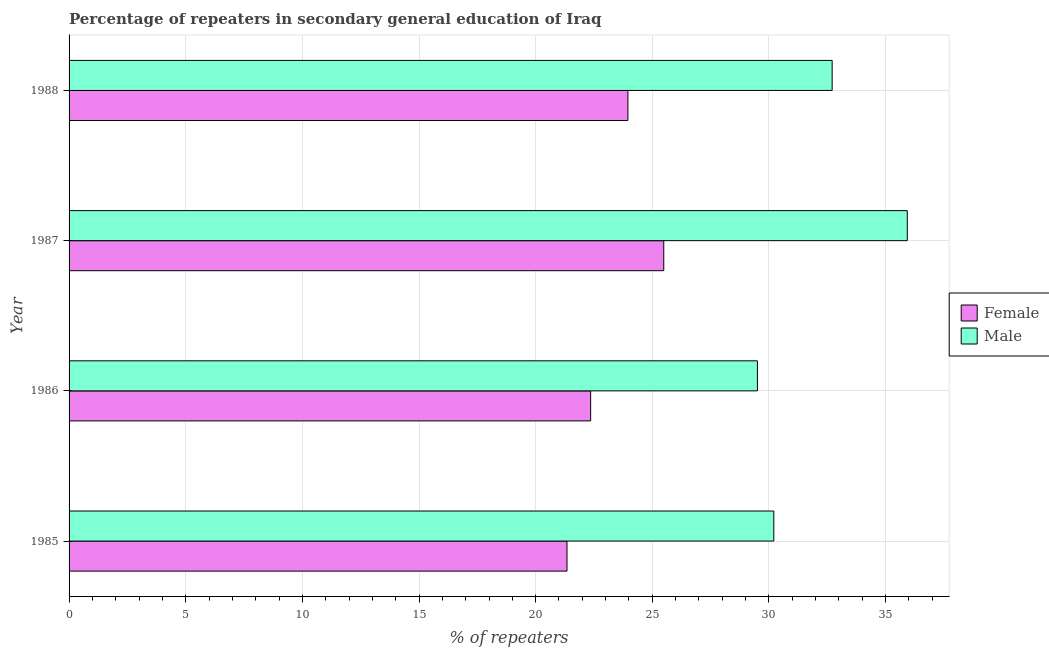How many groups of bars are there?
Give a very brief answer. 4. Are the number of bars on each tick of the Y-axis equal?
Your answer should be compact. Yes. How many bars are there on the 3rd tick from the bottom?
Your answer should be very brief. 2. What is the label of the 4th group of bars from the top?
Make the answer very short. 1985. In how many cases, is the number of bars for a given year not equal to the number of legend labels?
Your response must be concise. 0. What is the percentage of male repeaters in 1986?
Make the answer very short. 29.51. Across all years, what is the maximum percentage of female repeaters?
Make the answer very short. 25.49. Across all years, what is the minimum percentage of male repeaters?
Keep it short and to the point. 29.51. In which year was the percentage of female repeaters minimum?
Your answer should be very brief. 1985. What is the total percentage of male repeaters in the graph?
Your answer should be compact. 128.35. What is the difference between the percentage of male repeaters in 1985 and that in 1988?
Provide a short and direct response. -2.5. What is the difference between the percentage of female repeaters in 1985 and the percentage of male repeaters in 1987?
Ensure brevity in your answer.  -14.59. What is the average percentage of male repeaters per year?
Make the answer very short. 32.09. In the year 1985, what is the difference between the percentage of male repeaters and percentage of female repeaters?
Make the answer very short. 8.87. What is the ratio of the percentage of female repeaters in 1985 to that in 1988?
Your answer should be compact. 0.89. Is the percentage of male repeaters in 1986 less than that in 1988?
Provide a succinct answer. Yes. What is the difference between the highest and the second highest percentage of male repeaters?
Give a very brief answer. 3.22. What is the difference between the highest and the lowest percentage of female repeaters?
Ensure brevity in your answer.  4.15. How many bars are there?
Ensure brevity in your answer.  8. Are all the bars in the graph horizontal?
Give a very brief answer. Yes. How many years are there in the graph?
Your answer should be compact. 4. Does the graph contain any zero values?
Offer a very short reply. No. How many legend labels are there?
Make the answer very short. 2. How are the legend labels stacked?
Offer a very short reply. Vertical. What is the title of the graph?
Your answer should be very brief. Percentage of repeaters in secondary general education of Iraq. What is the label or title of the X-axis?
Provide a short and direct response. % of repeaters. What is the % of repeaters in Female in 1985?
Keep it short and to the point. 21.34. What is the % of repeaters of Male in 1985?
Your answer should be very brief. 30.21. What is the % of repeaters in Female in 1986?
Provide a succinct answer. 22.36. What is the % of repeaters in Male in 1986?
Offer a very short reply. 29.51. What is the % of repeaters of Female in 1987?
Provide a succinct answer. 25.49. What is the % of repeaters of Male in 1987?
Ensure brevity in your answer.  35.93. What is the % of repeaters in Female in 1988?
Make the answer very short. 23.95. What is the % of repeaters of Male in 1988?
Offer a terse response. 32.71. Across all years, what is the maximum % of repeaters of Female?
Provide a succinct answer. 25.49. Across all years, what is the maximum % of repeaters of Male?
Ensure brevity in your answer.  35.93. Across all years, what is the minimum % of repeaters of Female?
Your response must be concise. 21.34. Across all years, what is the minimum % of repeaters in Male?
Provide a short and direct response. 29.51. What is the total % of repeaters of Female in the graph?
Provide a short and direct response. 93.15. What is the total % of repeaters in Male in the graph?
Offer a terse response. 128.35. What is the difference between the % of repeaters in Female in 1985 and that in 1986?
Provide a short and direct response. -1.01. What is the difference between the % of repeaters in Male in 1985 and that in 1986?
Provide a succinct answer. 0.7. What is the difference between the % of repeaters of Female in 1985 and that in 1987?
Provide a short and direct response. -4.15. What is the difference between the % of repeaters in Male in 1985 and that in 1987?
Ensure brevity in your answer.  -5.72. What is the difference between the % of repeaters in Female in 1985 and that in 1988?
Ensure brevity in your answer.  -2.61. What is the difference between the % of repeaters in Male in 1985 and that in 1988?
Offer a very short reply. -2.5. What is the difference between the % of repeaters of Female in 1986 and that in 1987?
Provide a succinct answer. -3.13. What is the difference between the % of repeaters in Male in 1986 and that in 1987?
Keep it short and to the point. -6.42. What is the difference between the % of repeaters of Female in 1986 and that in 1988?
Provide a succinct answer. -1.6. What is the difference between the % of repeaters of Male in 1986 and that in 1988?
Offer a terse response. -3.2. What is the difference between the % of repeaters of Female in 1987 and that in 1988?
Offer a terse response. 1.54. What is the difference between the % of repeaters of Male in 1987 and that in 1988?
Provide a succinct answer. 3.22. What is the difference between the % of repeaters of Female in 1985 and the % of repeaters of Male in 1986?
Ensure brevity in your answer.  -8.16. What is the difference between the % of repeaters of Female in 1985 and the % of repeaters of Male in 1987?
Your answer should be compact. -14.59. What is the difference between the % of repeaters in Female in 1985 and the % of repeaters in Male in 1988?
Your answer should be very brief. -11.37. What is the difference between the % of repeaters in Female in 1986 and the % of repeaters in Male in 1987?
Offer a very short reply. -13.57. What is the difference between the % of repeaters of Female in 1986 and the % of repeaters of Male in 1988?
Give a very brief answer. -10.35. What is the difference between the % of repeaters of Female in 1987 and the % of repeaters of Male in 1988?
Ensure brevity in your answer.  -7.22. What is the average % of repeaters in Female per year?
Your answer should be very brief. 23.29. What is the average % of repeaters of Male per year?
Offer a very short reply. 32.09. In the year 1985, what is the difference between the % of repeaters in Female and % of repeaters in Male?
Make the answer very short. -8.87. In the year 1986, what is the difference between the % of repeaters of Female and % of repeaters of Male?
Your answer should be very brief. -7.15. In the year 1987, what is the difference between the % of repeaters of Female and % of repeaters of Male?
Offer a terse response. -10.44. In the year 1988, what is the difference between the % of repeaters in Female and % of repeaters in Male?
Keep it short and to the point. -8.75. What is the ratio of the % of repeaters in Female in 1985 to that in 1986?
Offer a very short reply. 0.95. What is the ratio of the % of repeaters of Male in 1985 to that in 1986?
Offer a terse response. 1.02. What is the ratio of the % of repeaters of Female in 1985 to that in 1987?
Make the answer very short. 0.84. What is the ratio of the % of repeaters in Male in 1985 to that in 1987?
Ensure brevity in your answer.  0.84. What is the ratio of the % of repeaters in Female in 1985 to that in 1988?
Give a very brief answer. 0.89. What is the ratio of the % of repeaters in Male in 1985 to that in 1988?
Your answer should be very brief. 0.92. What is the ratio of the % of repeaters of Female in 1986 to that in 1987?
Your answer should be very brief. 0.88. What is the ratio of the % of repeaters of Male in 1986 to that in 1987?
Your answer should be very brief. 0.82. What is the ratio of the % of repeaters in Female in 1986 to that in 1988?
Provide a succinct answer. 0.93. What is the ratio of the % of repeaters in Male in 1986 to that in 1988?
Your answer should be very brief. 0.9. What is the ratio of the % of repeaters of Female in 1987 to that in 1988?
Your response must be concise. 1.06. What is the ratio of the % of repeaters in Male in 1987 to that in 1988?
Provide a succinct answer. 1.1. What is the difference between the highest and the second highest % of repeaters of Female?
Offer a very short reply. 1.54. What is the difference between the highest and the second highest % of repeaters of Male?
Your answer should be compact. 3.22. What is the difference between the highest and the lowest % of repeaters in Female?
Your answer should be compact. 4.15. What is the difference between the highest and the lowest % of repeaters in Male?
Make the answer very short. 6.42. 